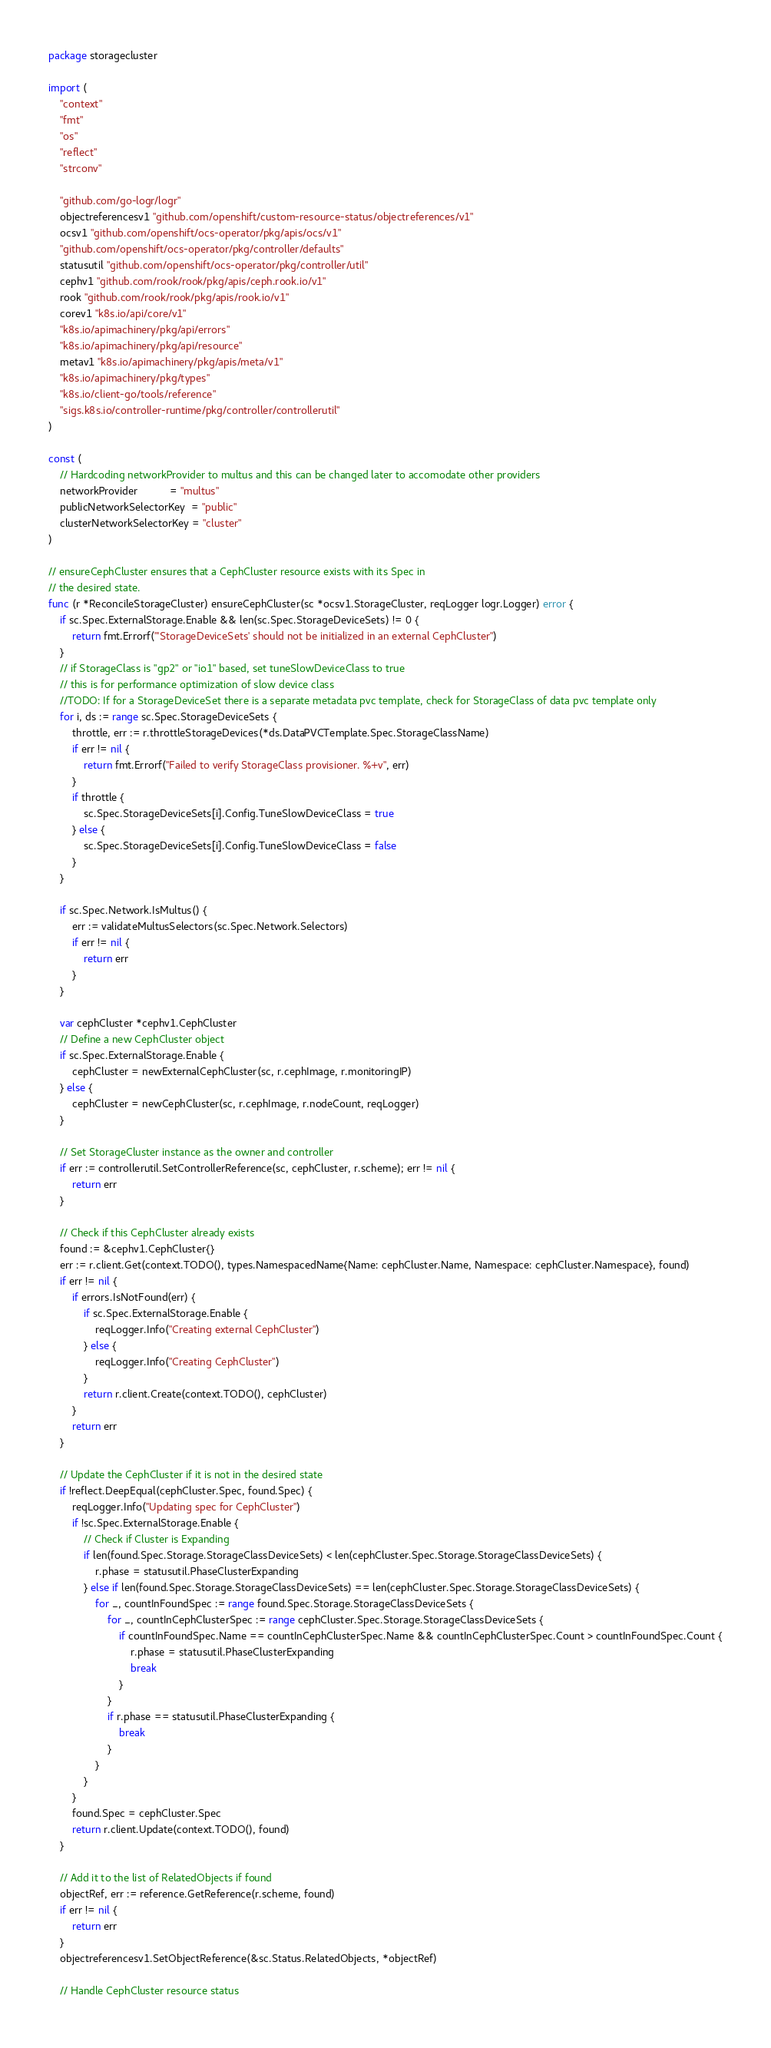<code> <loc_0><loc_0><loc_500><loc_500><_Go_>package storagecluster

import (
	"context"
	"fmt"
	"os"
	"reflect"
	"strconv"

	"github.com/go-logr/logr"
	objectreferencesv1 "github.com/openshift/custom-resource-status/objectreferences/v1"
	ocsv1 "github.com/openshift/ocs-operator/pkg/apis/ocs/v1"
	"github.com/openshift/ocs-operator/pkg/controller/defaults"
	statusutil "github.com/openshift/ocs-operator/pkg/controller/util"
	cephv1 "github.com/rook/rook/pkg/apis/ceph.rook.io/v1"
	rook "github.com/rook/rook/pkg/apis/rook.io/v1"
	corev1 "k8s.io/api/core/v1"
	"k8s.io/apimachinery/pkg/api/errors"
	"k8s.io/apimachinery/pkg/api/resource"
	metav1 "k8s.io/apimachinery/pkg/apis/meta/v1"
	"k8s.io/apimachinery/pkg/types"
	"k8s.io/client-go/tools/reference"
	"sigs.k8s.io/controller-runtime/pkg/controller/controllerutil"
)

const (
	// Hardcoding networkProvider to multus and this can be changed later to accomodate other providers
	networkProvider           = "multus"
	publicNetworkSelectorKey  = "public"
	clusterNetworkSelectorKey = "cluster"
)

// ensureCephCluster ensures that a CephCluster resource exists with its Spec in
// the desired state.
func (r *ReconcileStorageCluster) ensureCephCluster(sc *ocsv1.StorageCluster, reqLogger logr.Logger) error {
	if sc.Spec.ExternalStorage.Enable && len(sc.Spec.StorageDeviceSets) != 0 {
		return fmt.Errorf("'StorageDeviceSets' should not be initialized in an external CephCluster")
	}
	// if StorageClass is "gp2" or "io1" based, set tuneSlowDeviceClass to true
	// this is for performance optimization of slow device class
	//TODO: If for a StorageDeviceSet there is a separate metadata pvc template, check for StorageClass of data pvc template only
	for i, ds := range sc.Spec.StorageDeviceSets {
		throttle, err := r.throttleStorageDevices(*ds.DataPVCTemplate.Spec.StorageClassName)
		if err != nil {
			return fmt.Errorf("Failed to verify StorageClass provisioner. %+v", err)
		}
		if throttle {
			sc.Spec.StorageDeviceSets[i].Config.TuneSlowDeviceClass = true
		} else {
			sc.Spec.StorageDeviceSets[i].Config.TuneSlowDeviceClass = false
		}
	}

	if sc.Spec.Network.IsMultus() {
		err := validateMultusSelectors(sc.Spec.Network.Selectors)
		if err != nil {
			return err
		}
	}

	var cephCluster *cephv1.CephCluster
	// Define a new CephCluster object
	if sc.Spec.ExternalStorage.Enable {
		cephCluster = newExternalCephCluster(sc, r.cephImage, r.monitoringIP)
	} else {
		cephCluster = newCephCluster(sc, r.cephImage, r.nodeCount, reqLogger)
	}

	// Set StorageCluster instance as the owner and controller
	if err := controllerutil.SetControllerReference(sc, cephCluster, r.scheme); err != nil {
		return err
	}

	// Check if this CephCluster already exists
	found := &cephv1.CephCluster{}
	err := r.client.Get(context.TODO(), types.NamespacedName{Name: cephCluster.Name, Namespace: cephCluster.Namespace}, found)
	if err != nil {
		if errors.IsNotFound(err) {
			if sc.Spec.ExternalStorage.Enable {
				reqLogger.Info("Creating external CephCluster")
			} else {
				reqLogger.Info("Creating CephCluster")
			}
			return r.client.Create(context.TODO(), cephCluster)
		}
		return err
	}

	// Update the CephCluster if it is not in the desired state
	if !reflect.DeepEqual(cephCluster.Spec, found.Spec) {
		reqLogger.Info("Updating spec for CephCluster")
		if !sc.Spec.ExternalStorage.Enable {
			// Check if Cluster is Expanding
			if len(found.Spec.Storage.StorageClassDeviceSets) < len(cephCluster.Spec.Storage.StorageClassDeviceSets) {
				r.phase = statusutil.PhaseClusterExpanding
			} else if len(found.Spec.Storage.StorageClassDeviceSets) == len(cephCluster.Spec.Storage.StorageClassDeviceSets) {
				for _, countInFoundSpec := range found.Spec.Storage.StorageClassDeviceSets {
					for _, countInCephClusterSpec := range cephCluster.Spec.Storage.StorageClassDeviceSets {
						if countInFoundSpec.Name == countInCephClusterSpec.Name && countInCephClusterSpec.Count > countInFoundSpec.Count {
							r.phase = statusutil.PhaseClusterExpanding
							break
						}
					}
					if r.phase == statusutil.PhaseClusterExpanding {
						break
					}
				}
			}
		}
		found.Spec = cephCluster.Spec
		return r.client.Update(context.TODO(), found)
	}

	// Add it to the list of RelatedObjects if found
	objectRef, err := reference.GetReference(r.scheme, found)
	if err != nil {
		return err
	}
	objectreferencesv1.SetObjectReference(&sc.Status.RelatedObjects, *objectRef)

	// Handle CephCluster resource status</code> 